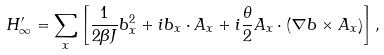<formula> <loc_0><loc_0><loc_500><loc_500>H ^ { \prime } _ { \infty } = \sum _ { x } \left [ \frac { 1 } { 2 \beta J } { b } _ { x } ^ { 2 } + i { b } _ { x } \cdot { A } _ { x } + i \frac { \theta } { 2 } { A } _ { x } \cdot ( \nabla b \times { A } _ { x } ) \right ] ,</formula> 